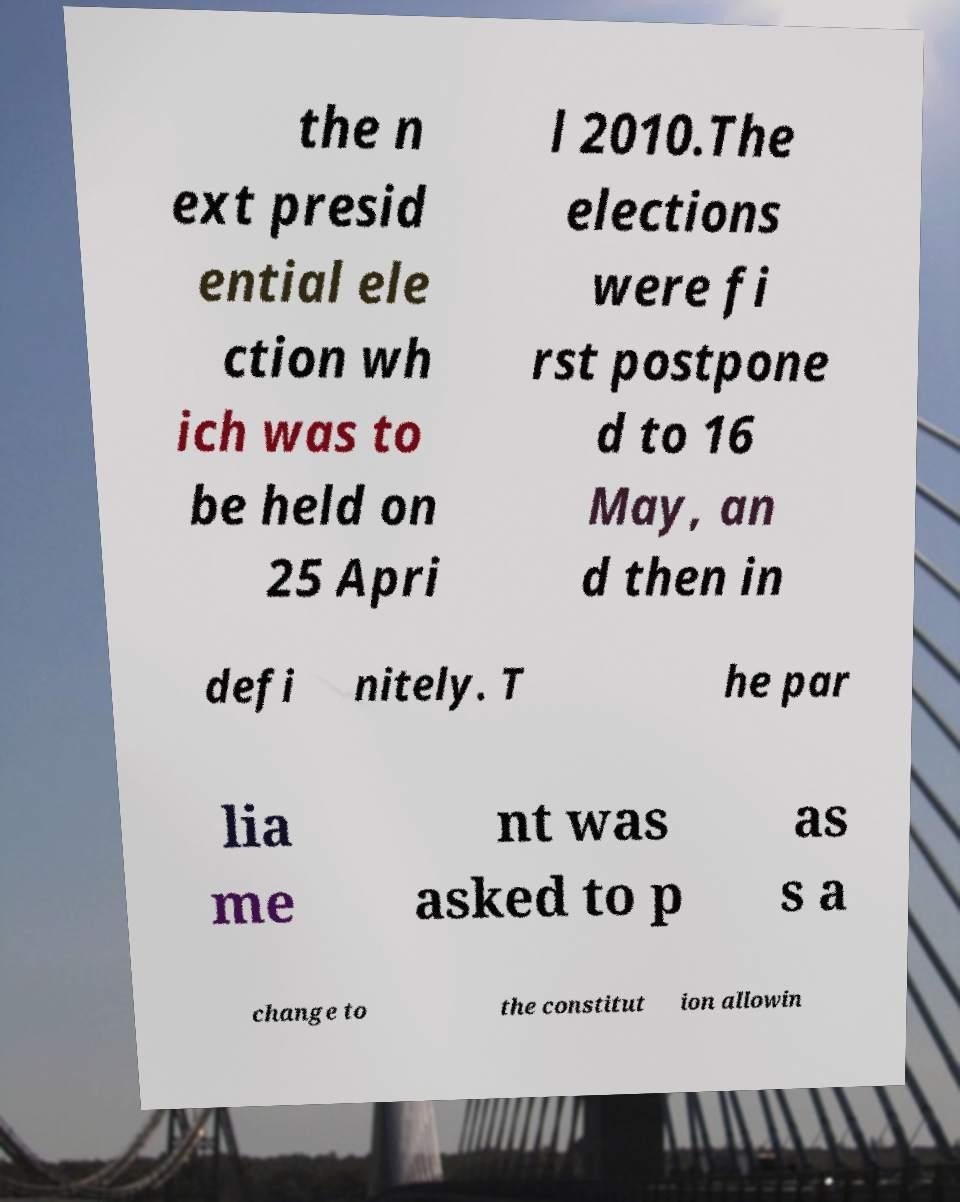Please read and relay the text visible in this image. What does it say? the n ext presid ential ele ction wh ich was to be held on 25 Apri l 2010.The elections were fi rst postpone d to 16 May, an d then in defi nitely. T he par lia me nt was asked to p as s a change to the constitut ion allowin 